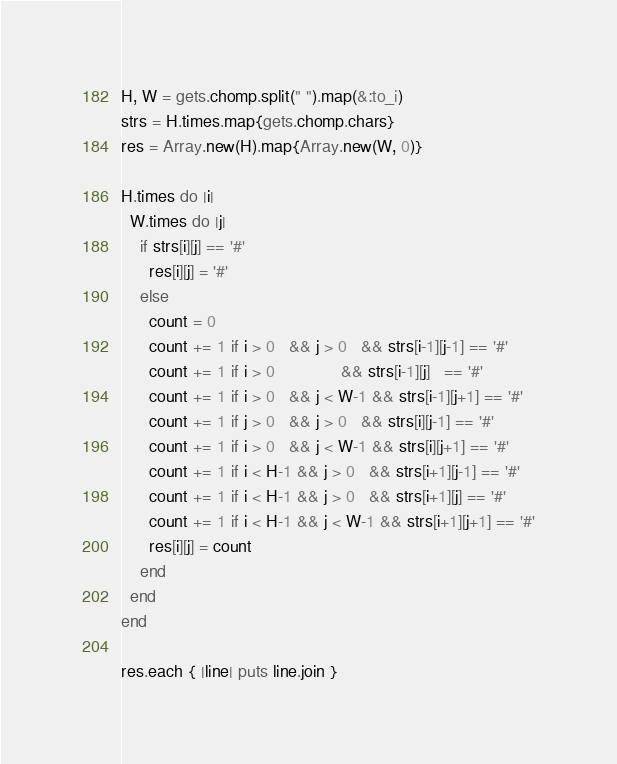Convert code to text. <code><loc_0><loc_0><loc_500><loc_500><_Ruby_>H, W = gets.chomp.split(" ").map(&:to_i)
strs = H.times.map{gets.chomp.chars}
res = Array.new(H).map{Array.new(W, 0)}

H.times do |i|
  W.times do |j|
    if strs[i][j] == '#'
      res[i][j] = '#'
    else
      count = 0
      count += 1 if i > 0   && j > 0   && strs[i-1][j-1] == '#'
      count += 1 if i > 0              && strs[i-1][j]   == '#'
      count += 1 if i > 0   && j < W-1 && strs[i-1][j+1] == '#'
      count += 1 if j > 0   && j > 0   && strs[i][j-1] == '#'
      count += 1 if i > 0   && j < W-1 && strs[i][j+1] == '#'
      count += 1 if i < H-1 && j > 0   && strs[i+1][j-1] == '#'
      count += 1 if i < H-1 && j > 0   && strs[i+1][j] == '#'
      count += 1 if i < H-1 && j < W-1 && strs[i+1][j+1] == '#'
      res[i][j] = count
    end
  end
end

res.each { |line| puts line.join }</code> 